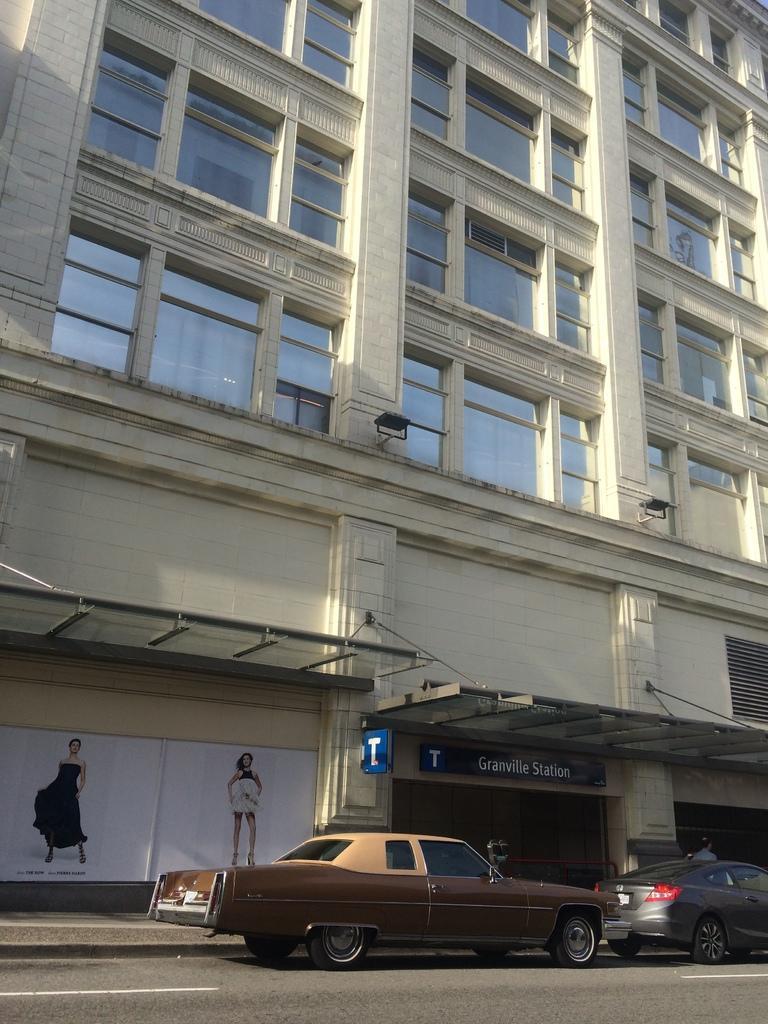How would you summarize this image in a sentence or two? In the center of the image we can see two vehicles on the road. In the background there is a building, wall, glass, banners, sign boards, one person is standing and a few other objects. On the banners, we can see two persons are standing and they are in different costumes. 